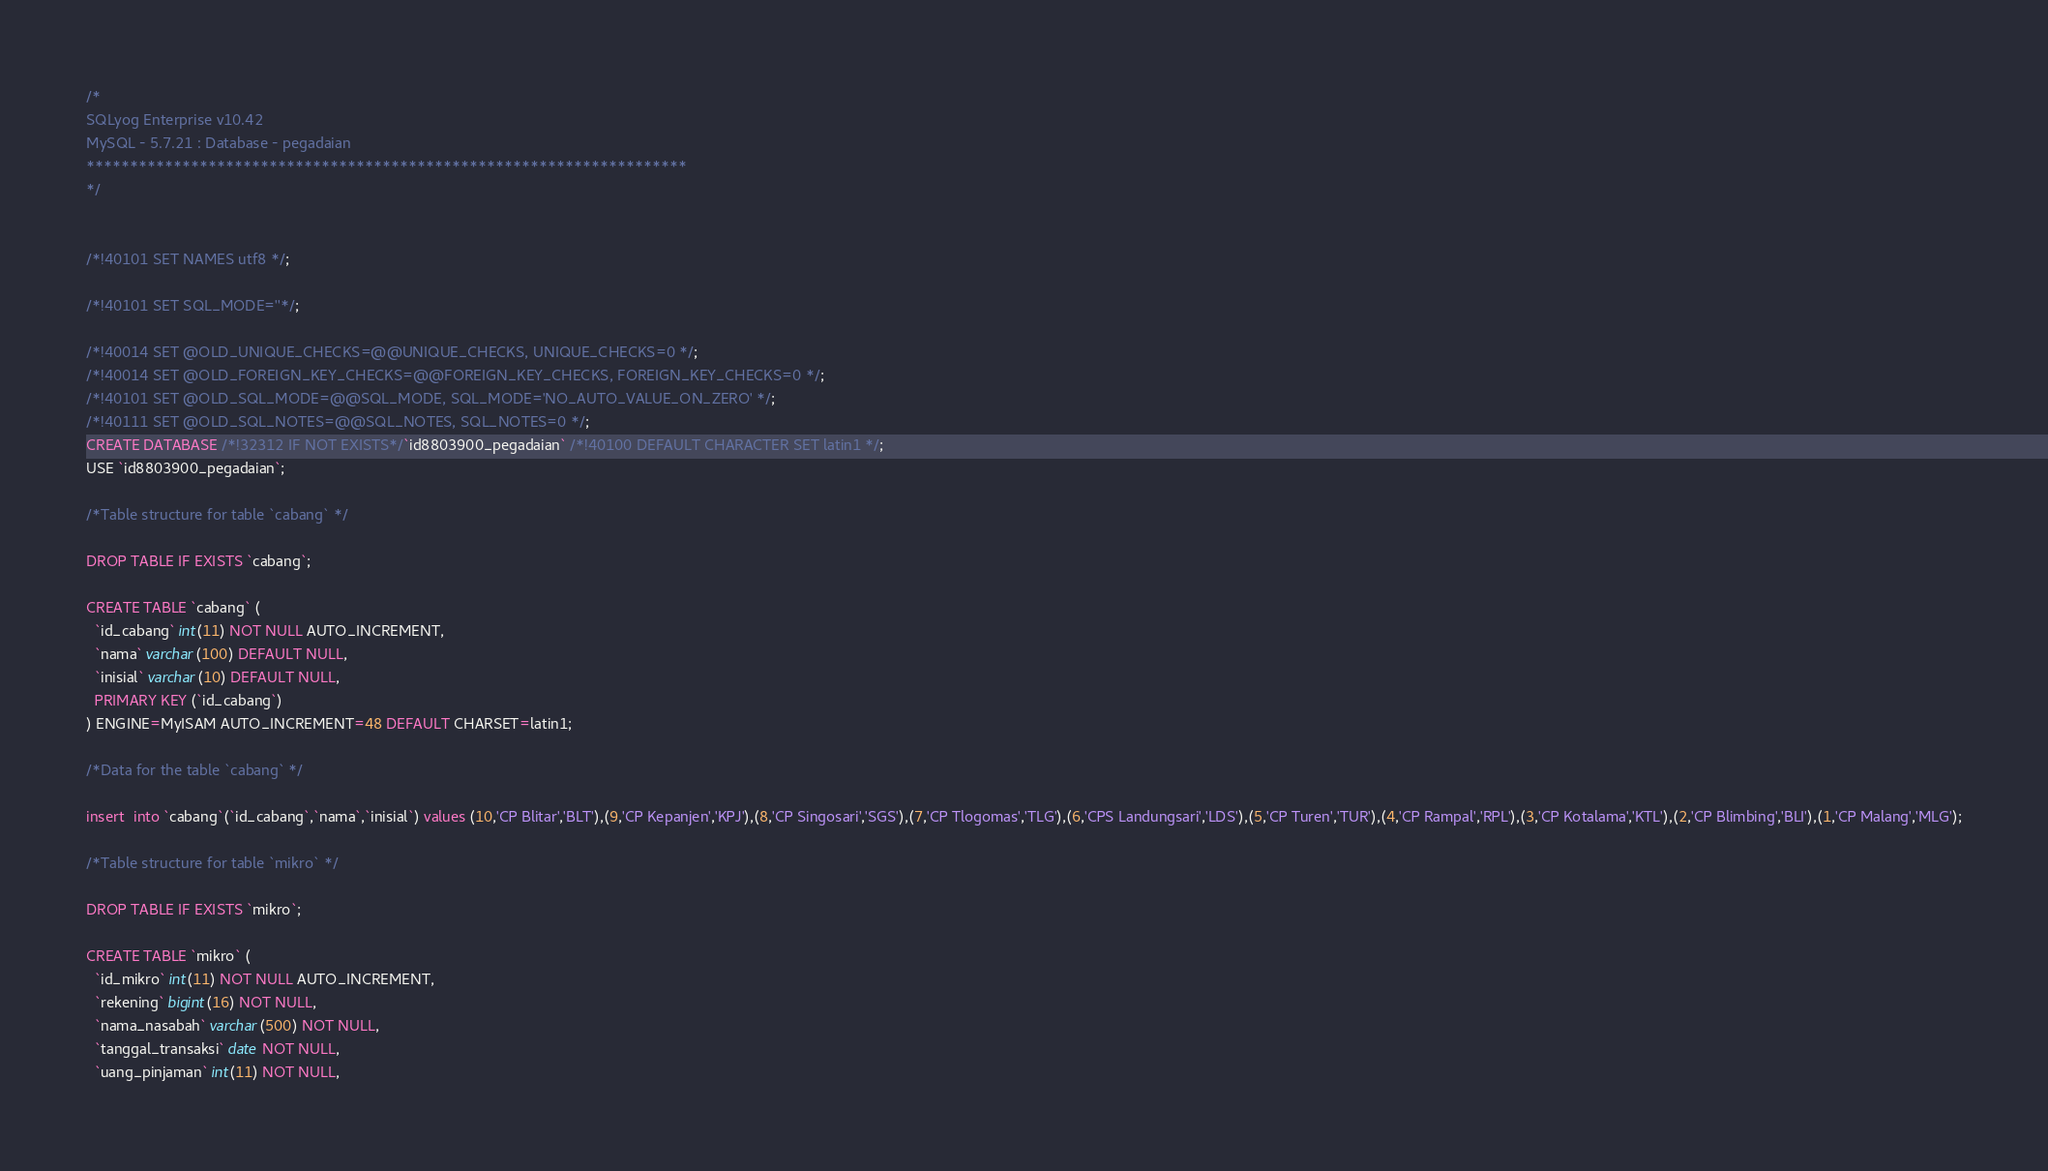Convert code to text. <code><loc_0><loc_0><loc_500><loc_500><_SQL_>/*
SQLyog Enterprise v10.42 
MySQL - 5.7.21 : Database - pegadaian
*********************************************************************
*/


/*!40101 SET NAMES utf8 */;

/*!40101 SET SQL_MODE=''*/;

/*!40014 SET @OLD_UNIQUE_CHECKS=@@UNIQUE_CHECKS, UNIQUE_CHECKS=0 */;
/*!40014 SET @OLD_FOREIGN_KEY_CHECKS=@@FOREIGN_KEY_CHECKS, FOREIGN_KEY_CHECKS=0 */;
/*!40101 SET @OLD_SQL_MODE=@@SQL_MODE, SQL_MODE='NO_AUTO_VALUE_ON_ZERO' */;
/*!40111 SET @OLD_SQL_NOTES=@@SQL_NOTES, SQL_NOTES=0 */;
CREATE DATABASE /*!32312 IF NOT EXISTS*/`id8803900_pegadaian` /*!40100 DEFAULT CHARACTER SET latin1 */;
USE `id8803900_pegadaian`;

/*Table structure for table `cabang` */

DROP TABLE IF EXISTS `cabang`;

CREATE TABLE `cabang` (
  `id_cabang` int(11) NOT NULL AUTO_INCREMENT,
  `nama` varchar(100) DEFAULT NULL,
  `inisial` varchar(10) DEFAULT NULL,
  PRIMARY KEY (`id_cabang`)
) ENGINE=MyISAM AUTO_INCREMENT=48 DEFAULT CHARSET=latin1;

/*Data for the table `cabang` */

insert  into `cabang`(`id_cabang`,`nama`,`inisial`) values (10,'CP Blitar','BLT'),(9,'CP Kepanjen','KPJ'),(8,'CP Singosari','SGS'),(7,'CP Tlogomas','TLG'),(6,'CPS Landungsari','LDS'),(5,'CP Turen','TUR'),(4,'CP Rampal','RPL'),(3,'CP Kotalama','KTL'),(2,'CP Blimbing','BLI'),(1,'CP Malang','MLG');

/*Table structure for table `mikro` */

DROP TABLE IF EXISTS `mikro`;

CREATE TABLE `mikro` (
  `id_mikro` int(11) NOT NULL AUTO_INCREMENT,
  `rekening` bigint(16) NOT NULL,
  `nama_nasabah` varchar(500) NOT NULL,
  `tanggal_transaksi` date NOT NULL,
  `uang_pinjaman` int(11) NOT NULL,</code> 